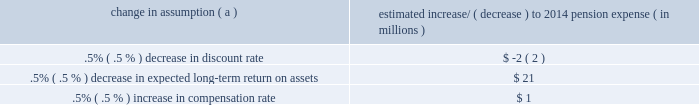The table below reflects the estimated effects on pension expense of certain changes in annual assumptions , using 2014 estimated expense as a baseline .
Table 29 : pension expense 2013 sensitivity analysis change in assumption ( a ) estimated increase/ ( decrease ) to 2014 pension expense ( in millions ) .
( a ) the impact is the effect of changing the specified assumption while holding all other assumptions constant .
Our pension plan contribution requirements are not particularly sensitive to actuarial assumptions .
Investment performance has the most impact on contribution requirements and will drive the amount of required contributions in future years .
Also , current law , including the provisions of the pension protection act of 2006 , sets limits as to both minimum and maximum contributions to the plan .
We do not expect to be required by law to make any contributions to the plan during 2014 .
We maintain other defined benefit plans that have a less significant effect on financial results , including various nonqualified supplemental retirement plans for certain employees , which are described more fully in note 15 employee benefit plans in the notes to consolidated financial statements in item 8 of this report .
Recourse and repurchase obligations as discussed in note 3 loan sale and servicing activities and variable interest entities in the notes to consolidated financial statements in item 8 of this report , pnc has sold commercial mortgage , residential mortgage and home equity loans directly or indirectly through securitization and loan sale transactions in which we have continuing involvement .
One form of continuing involvement includes certain recourse and loan repurchase obligations associated with the transferred assets .
Commercial mortgage loan recourse obligations we originate , close and service certain multi-family commercial mortgage loans which are sold to fnma under fnma 2019s delegated underwriting and servicing ( dus ) program .
We participated in a similar program with the fhlmc .
Our exposure and activity associated with these recourse obligations are reported in the corporate & institutional banking segment .
For more information regarding our commercial mortgage loan recourse obligations , see the recourse and repurchase obligations section of note 24 commitments and guarantees included in the notes to consolidated financial statements in item 8 of this report .
Residential mortgage repurchase obligations while residential mortgage loans are sold on a non-recourse basis , we assume certain loan repurchase obligations associated with mortgage loans we have sold to investors .
These loan repurchase obligations primarily relate to situations where pnc is alleged to have breached certain origination covenants and representations and warranties made to purchasers of the loans in the respective purchase and sale agreements .
Residential mortgage loans covered by these loan repurchase obligations include first and second-lien mortgage loans we have sold through agency securitizations , non-agency securitizations , and loan sale transactions .
As discussed in note 3 in the notes to consolidated financial statements in item 8 of this report , agency securitizations consist of mortgage loan sale transactions with fnma , fhlmc and the government national mortgage association ( gnma ) , while non-agency securitizations consist of mortgage loan sale transactions with private investors .
Mortgage loan sale transactions that are not part of a securitization may involve fnma , fhlmc or private investors .
Our historical exposure and activity associated with agency securitization repurchase obligations has primarily been related to transactions with fnma and fhlmc , as indemnification and repurchase losses associated with fha and va-insured and uninsured loans pooled in gnma securitizations historically have been minimal .
Repurchase obligation activity associated with residential mortgages is reported in the residential mortgage banking segment .
Loan covenants and representations and warranties are established through loan sale agreements with various investors to provide assurance that pnc has sold loans that are of sufficient investment quality .
Key aspects of such covenants and representations and warranties include the loan 2019s compliance with any applicable loan criteria established for the transaction , including underwriting standards , delivery of all required loan documents to the investor or its designated party , sufficient collateral valuation and the validity of the lien securing the loan .
As a result of alleged breaches of these contractual obligations , investors may request pnc to indemnify them against losses on certain loans or to repurchase loans .
We investigate every investor claim on a loan by loan basis to determine the existence of a legitimate claim and that all other conditions for indemnification or repurchase have been met prior to the settlement with that investor .
Indemnifications for loss or loan repurchases typically occur when , after review of the claim , we agree insufficient evidence exists to dispute the investor 2019s claim that a breach of a loan covenant and representation and warranty has occurred , such breach has not been cured and the effect of such breach is deemed to have had a material and adverse effect on the value of the transferred loan .
Depending on the sale agreement and upon proper notice from the investor , we typically respond to such indemnification and repurchase requests within 60 days , although final resolution of the claim may take a longer period of time .
With the exception of the sales agreements associated the pnc financial services group , inc .
2013 form 10-k 67 .
What is the difference in millions on the pension expense effect of a .5% ( .5 % ) decrease in expected long-term return on assets compared to a .5% ( .5 % ) increase in compensation rate? 
Computations: (21 - 1)
Answer: 20.0. 